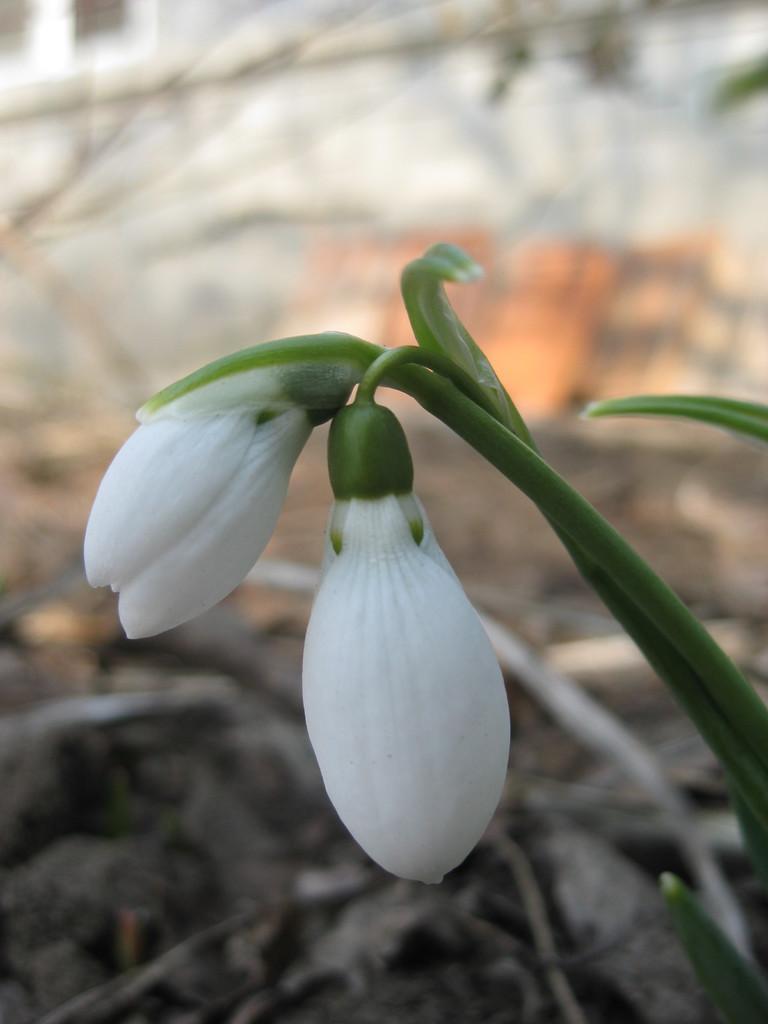Please provide a concise description of this image. In the picture we can see a small plant with two flower buds which are white in color and behind it, we can see some dried twigs which are not clearly visible. 